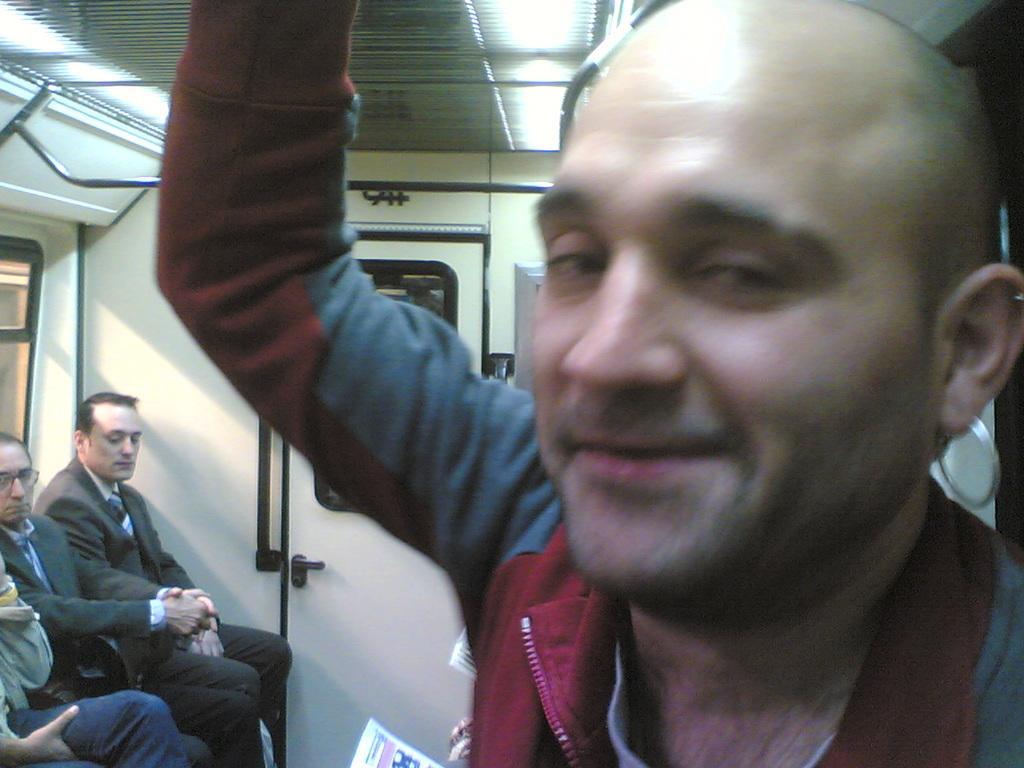How would you summarize this image in a sentence or two? In this image in the front there is a man smiling. In the background on the left side there are persons sitting, there is a window and there is a door. On the top there are rods and there is an object which is white in colour at the bottom. 